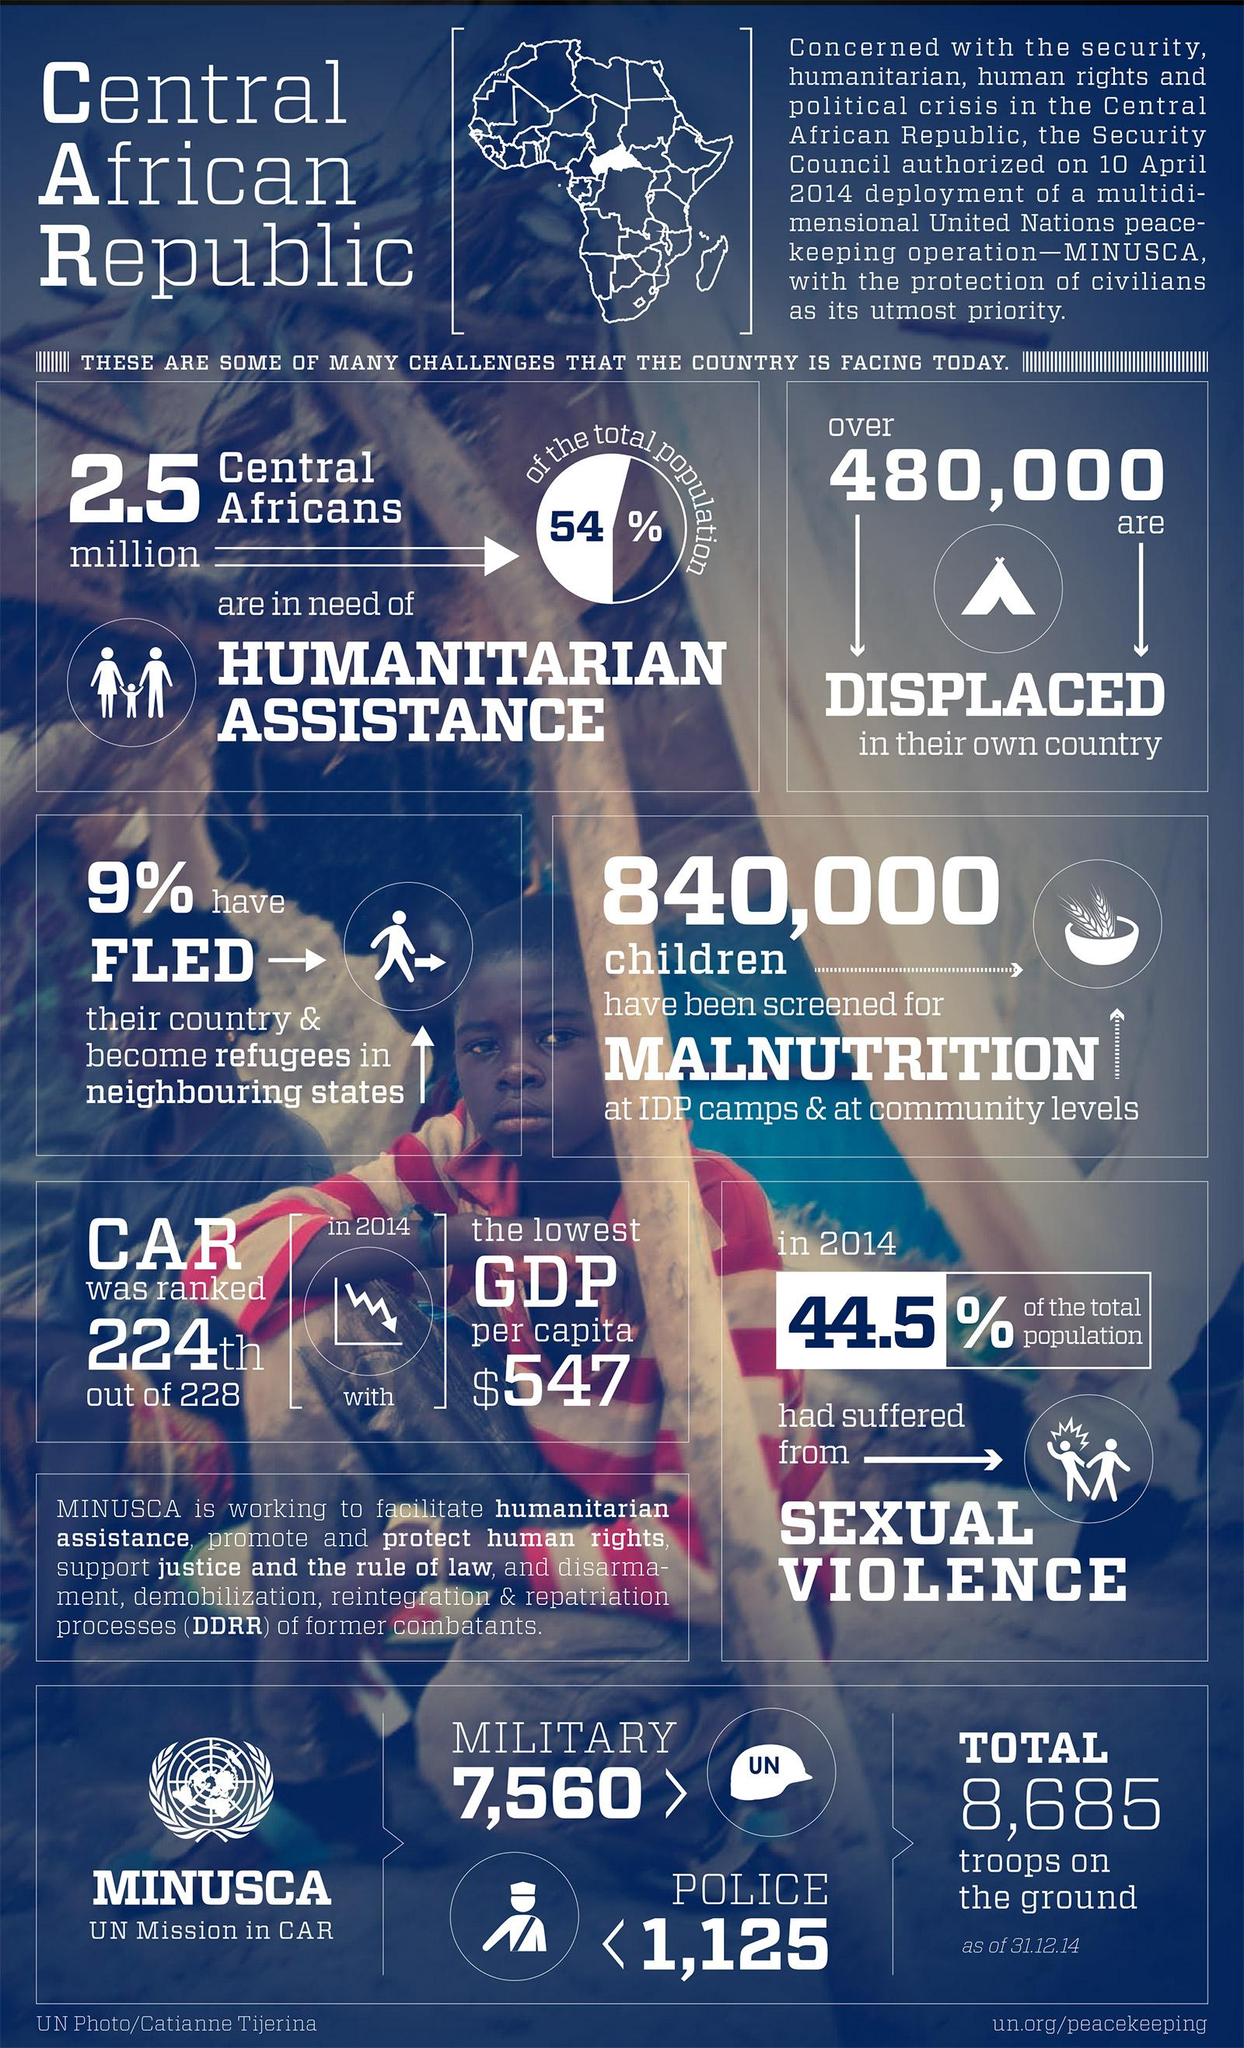Draw attention to some important aspects in this diagram. In 2014, it was estimated that 44.5% of the population had suffered sexual violence. It is estimated that 2.5 million people in the Central African Republic require humanitarian assistance. There are currently 8,685 ground troops deployed in the Central African Republic. Over 480,000 Central Africans are displaced within their own country as a result of conflict and violence. As of 2021, the Central African Republic has approximately 7,560 military troops. 